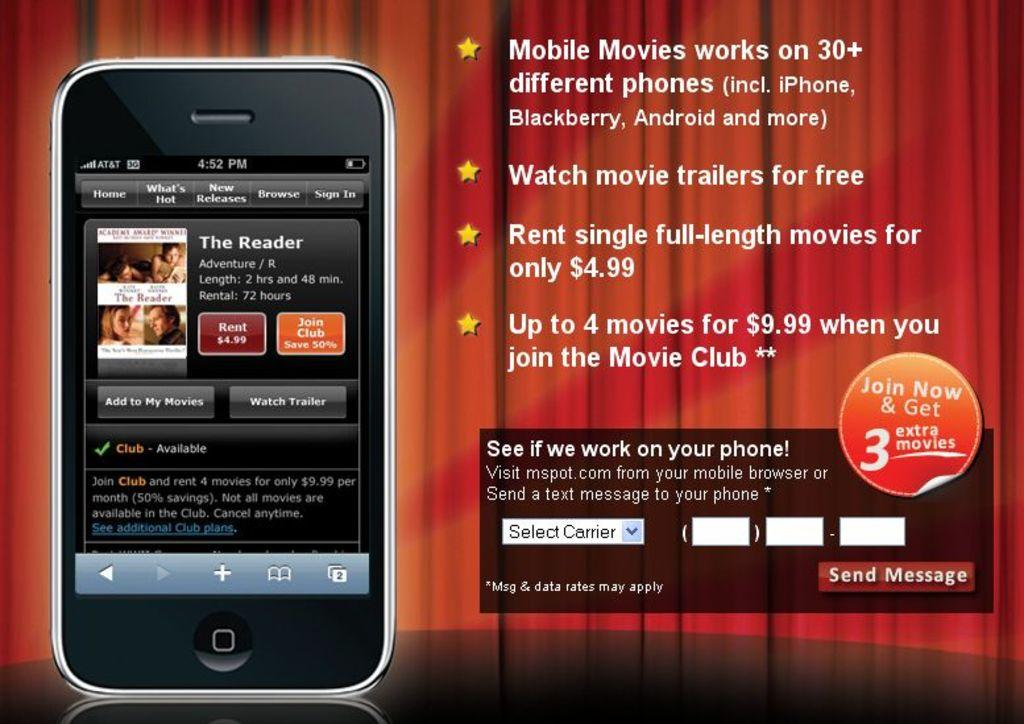What electronic device is visible in the image? There is a mobile phone in the image. What can be seen on the right side of the image? There is writing on the right side of the image. What type of curtains are present in the image? There are red curtains at the back of the image. How many toes are visible in the image? There are no toes visible in the image. What type of thread is being used to create the story in the image? There is no story or thread present in the image. 